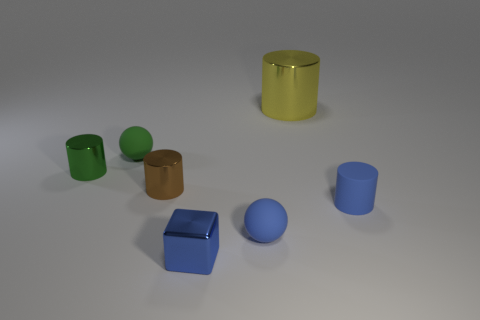Is the tiny blue cylinder made of the same material as the tiny brown cylinder that is on the left side of the rubber cylinder?
Keep it short and to the point. No. How many matte objects are either small objects or small blue cubes?
Provide a short and direct response. 3. There is a rubber thing that is the same shape as the large yellow metallic object; what color is it?
Offer a very short reply. Blue. How many objects are either metal cubes or blue cylinders?
Keep it short and to the point. 2. There is a tiny blue object that is the same material as the small green cylinder; what shape is it?
Your answer should be compact. Cube. How many large things are yellow objects or purple things?
Make the answer very short. 1. How many other objects are the same color as the tiny rubber cylinder?
Your response must be concise. 2. There is a small rubber object behind the blue rubber object right of the blue matte ball; how many small cylinders are to the left of it?
Your response must be concise. 1. Does the rubber thing to the left of the blue sphere have the same size as the yellow thing?
Your answer should be very brief. No. Is the number of big metallic cylinders behind the small green cylinder less than the number of green shiny cylinders in front of the brown shiny thing?
Make the answer very short. No. 